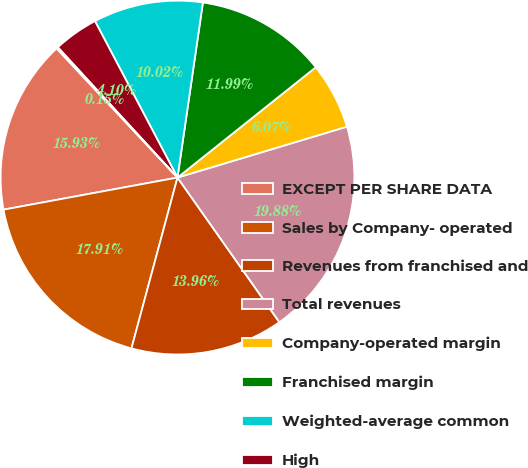Convert chart. <chart><loc_0><loc_0><loc_500><loc_500><pie_chart><fcel>EXCEPT PER SHARE DATA<fcel>Sales by Company- operated<fcel>Revenues from franchised and<fcel>Total revenues<fcel>Company-operated margin<fcel>Franchised margin<fcel>Weighted-average common<fcel>High<fcel>Low<nl><fcel>15.93%<fcel>17.91%<fcel>13.96%<fcel>19.88%<fcel>6.07%<fcel>11.99%<fcel>10.02%<fcel>4.1%<fcel>0.15%<nl></chart> 